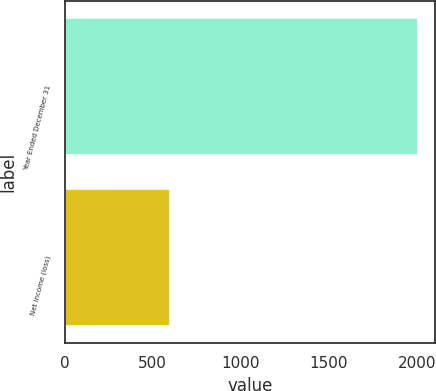Convert chart to OTSL. <chart><loc_0><loc_0><loc_500><loc_500><bar_chart><fcel>Year Ended December 31<fcel>Net income (loss)<nl><fcel>2003<fcel>598.6<nl></chart> 